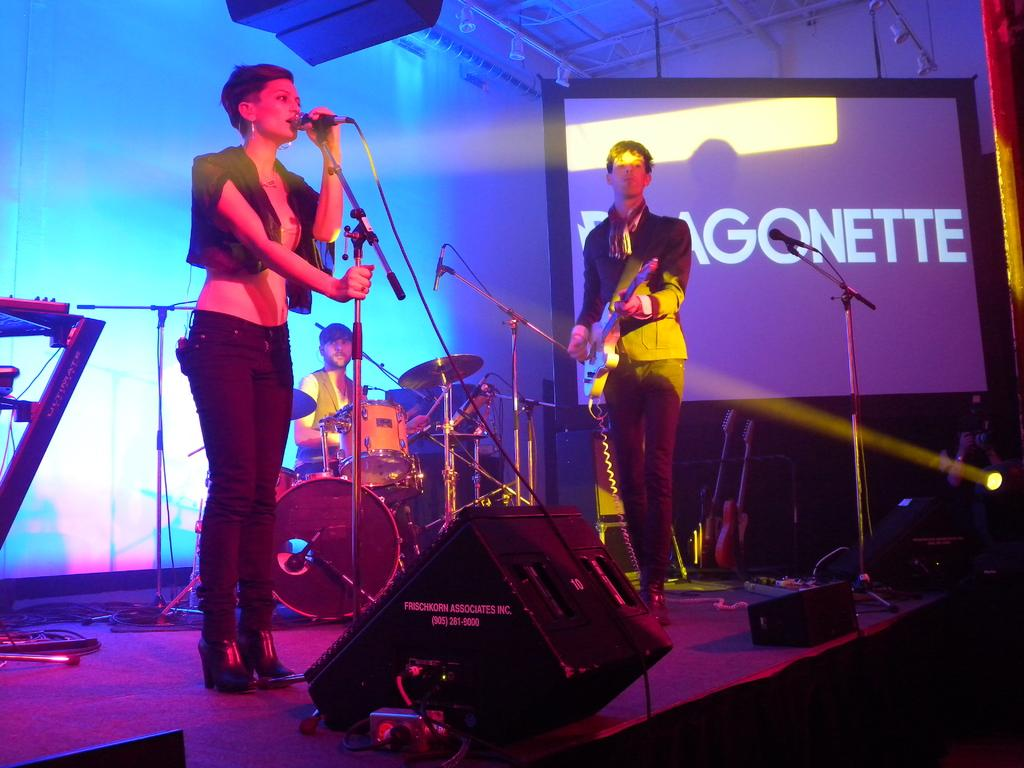How many people are in the image? There are three people in the image. What are the people doing in the image? The people are playing musical instruments. Can you describe anything to the right of the image? There is a screen to the right of the image. What type of cheese can be seen on the tub in the image? There is no cheese or tub present in the image. What word is written on the screen in the image? The provided facts do not mention any words on the screen, so we cannot answer this question. 